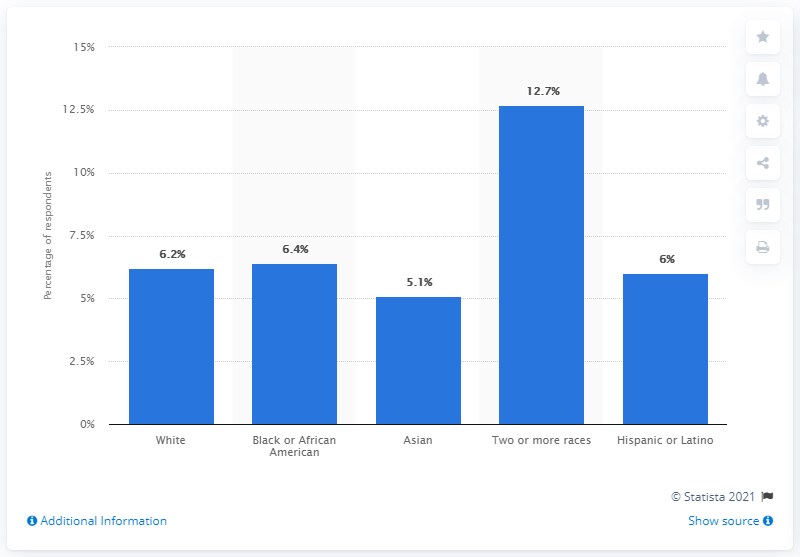Point out several critical features in this image. According to a recent study, 5.1% of Asian children had food allergies in the past year. 